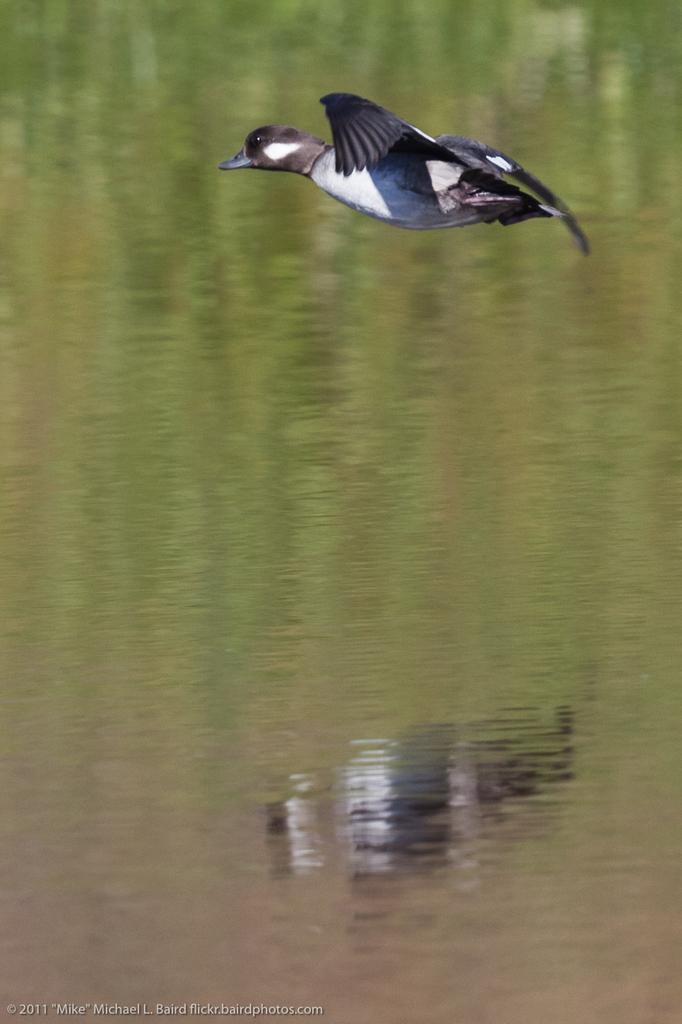Could you give a brief overview of what you see in this image? In the image we can see a bird flying. Here we can see water and on the water we can see blur reflection of the bird. In the image bottom left, we can see the watermark. 